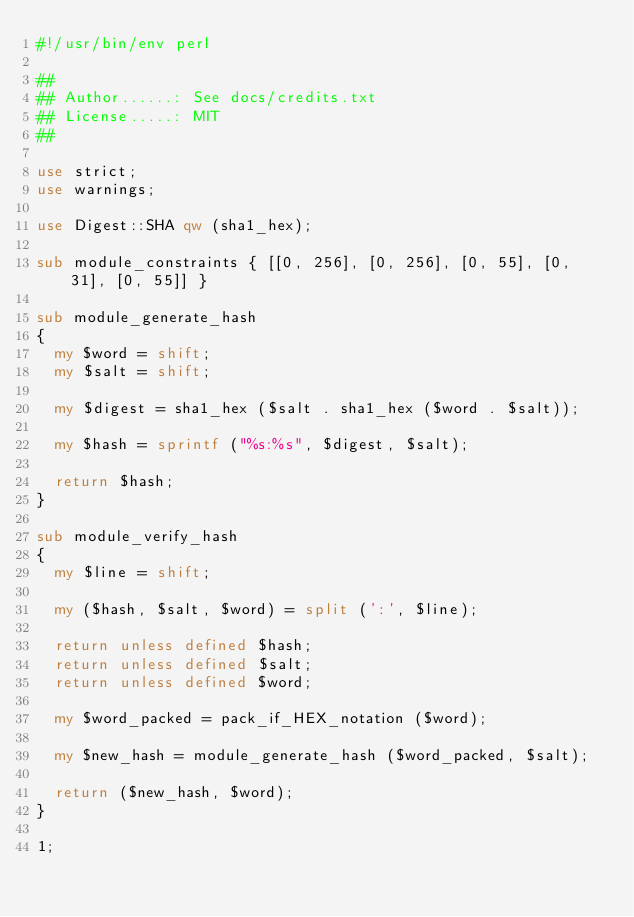Convert code to text. <code><loc_0><loc_0><loc_500><loc_500><_Perl_>#!/usr/bin/env perl

##
## Author......: See docs/credits.txt
## License.....: MIT
##

use strict;
use warnings;

use Digest::SHA qw (sha1_hex);

sub module_constraints { [[0, 256], [0, 256], [0, 55], [0, 31], [0, 55]] }

sub module_generate_hash
{
  my $word = shift;
  my $salt = shift;

  my $digest = sha1_hex ($salt . sha1_hex ($word . $salt));

  my $hash = sprintf ("%s:%s", $digest, $salt);

  return $hash;
}

sub module_verify_hash
{
  my $line = shift;

  my ($hash, $salt, $word) = split (':', $line);

  return unless defined $hash;
  return unless defined $salt;
  return unless defined $word;

  my $word_packed = pack_if_HEX_notation ($word);

  my $new_hash = module_generate_hash ($word_packed, $salt);

  return ($new_hash, $word);
}

1;
</code> 